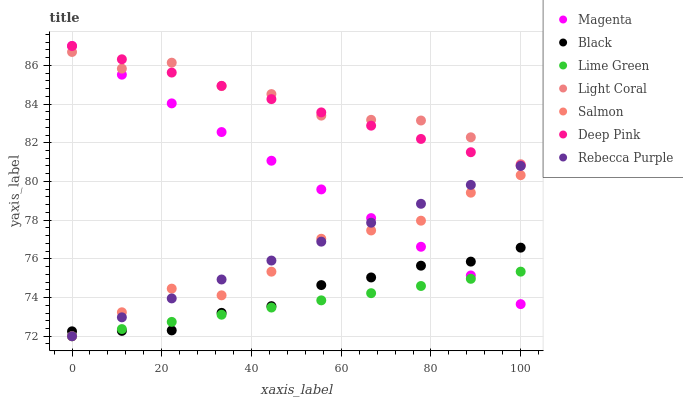Does Lime Green have the minimum area under the curve?
Answer yes or no. Yes. Does Light Coral have the maximum area under the curve?
Answer yes or no. Yes. Does Salmon have the minimum area under the curve?
Answer yes or no. No. Does Salmon have the maximum area under the curve?
Answer yes or no. No. Is Magenta the smoothest?
Answer yes or no. Yes. Is Light Coral the roughest?
Answer yes or no. Yes. Is Salmon the smoothest?
Answer yes or no. No. Is Salmon the roughest?
Answer yes or no. No. Does Salmon have the lowest value?
Answer yes or no. Yes. Does Light Coral have the lowest value?
Answer yes or no. No. Does Magenta have the highest value?
Answer yes or no. Yes. Does Salmon have the highest value?
Answer yes or no. No. Is Black less than Light Coral?
Answer yes or no. Yes. Is Deep Pink greater than Rebecca Purple?
Answer yes or no. Yes. Does Salmon intersect Black?
Answer yes or no. Yes. Is Salmon less than Black?
Answer yes or no. No. Is Salmon greater than Black?
Answer yes or no. No. Does Black intersect Light Coral?
Answer yes or no. No. 